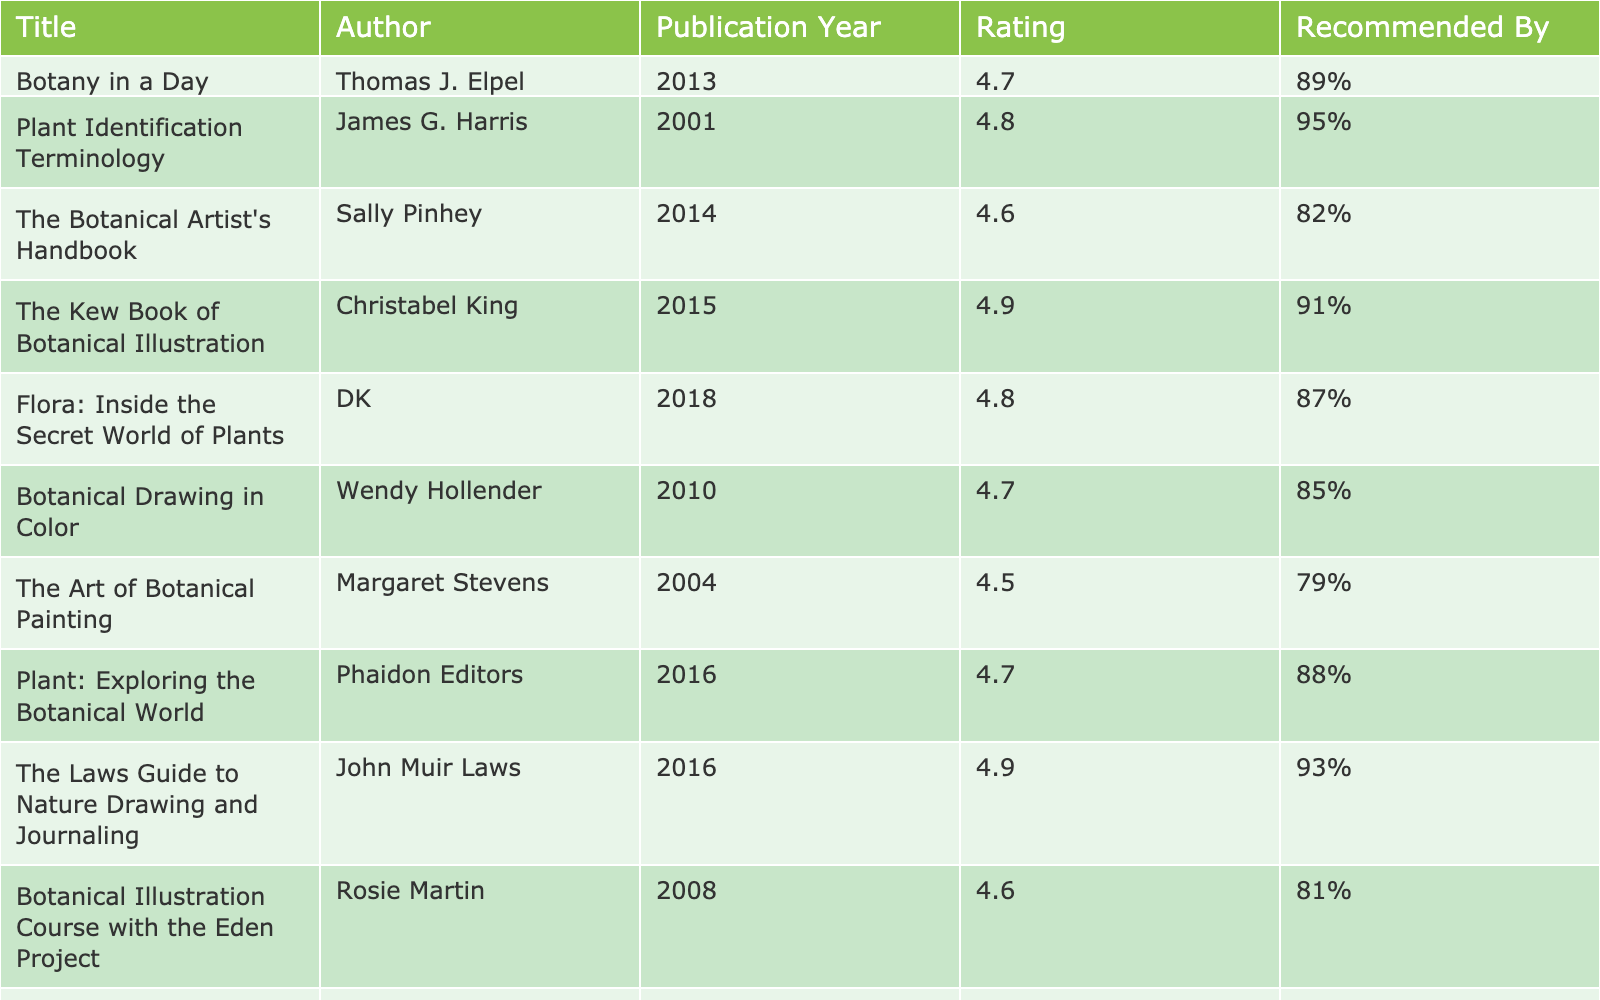What is the book with the highest rating? The highest rating in the table is found by looking at the 'Rating' column. The 'Kew Book of Botanical Illustration' has a rating of 4.9, which is the highest in the list.
Answer: The Kew Book of Botanical Illustration Which book was recommended by the most people? The recommendation percentage indicates the popularity of the books. 'Plant Identification Terminology' has the highest recommendation rate at 95%, which suggests it was recommended by the most people.
Answer: Plant Identification Terminology What is the average rating of the books listed? To find the average, sum all ratings: (4.7 + 4.8 + 4.6 + 4.9 + 4.8 + 4.7 + 4.5 + 4.7 + 4.9 + 4.6 + 4.7 + 4.8 + 4.7 + 4.6 + 4.5) = 70.1. There are 15 books, so dividing gives 70.1/15 = 4.673.
Answer: 4.67 Is there a book with a rating below 4.5? By inspecting the 'Rating' column and checking for any value below 4.5, we find that 'Botanical Drawing Using Graphite and Coloured Pencils' has a rating of 4.5, which is not below 4.5. Therefore, the answer is no.
Answer: No How many books have a recommendation rate of 90% or higher? We check the 'Recommended By' column for values of 90% or above. From the list, there are 7 books that meet this criterion.
Answer: 7 Which book has the lowest recommendation rate? The lowest recommendation percentage is found by searching the 'Recommended By' column. 'Botanical Drawing Using Graphite and Coloured Pencils' has the lowest rate at 78%.
Answer: Botanical Drawing Using Graphite and Coloured Pencils Are there more books published after 2010 or before? We compare the publication years. There are 9 books published after 2010 and 6 books published before 2010, indicating there are more published after.
Answer: More published after 2010 Identify the author of 'The Botanical Artist's Handbook'. By looking at the 'Title' column for 'The Botanical Artist's Handbook' and finding the corresponding author in the same row, we see that the author is Sally Pinhey.
Answer: Sally Pinhey What is the difference between the highest and lowest rated books? The highest rated book is 'The Kew Book of Botanical Illustration' with a rating of 4.9, and the lowest rated book listed is 'Botanical Drawing Using Graphite and Coloured Pencils' with a 4.5 rating. The difference is 4.9 - 4.5 = 0.4.
Answer: 0.4 Which author has the most books listed in this table? By analyzing the authors in the 'Author' column and tallying their occurrences, it can be observed that no single author appears more than once in this specific table of books.
Answer: None 